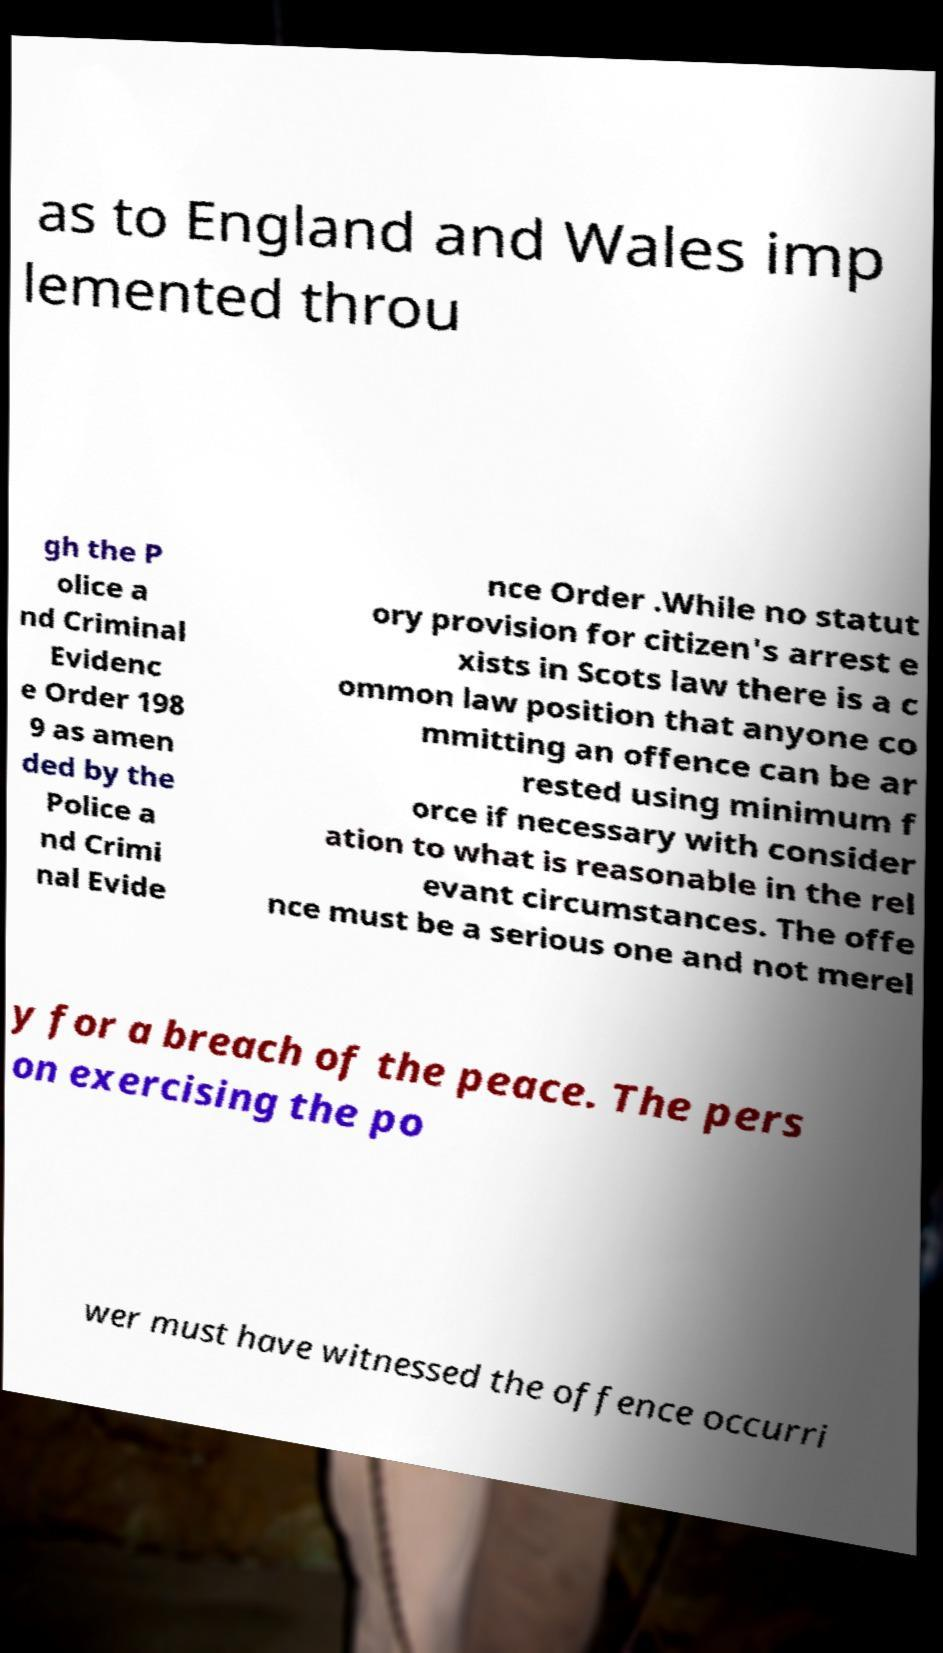Could you assist in decoding the text presented in this image and type it out clearly? as to England and Wales imp lemented throu gh the P olice a nd Criminal Evidenc e Order 198 9 as amen ded by the Police a nd Crimi nal Evide nce Order .While no statut ory provision for citizen's arrest e xists in Scots law there is a c ommon law position that anyone co mmitting an offence can be ar rested using minimum f orce if necessary with consider ation to what is reasonable in the rel evant circumstances. The offe nce must be a serious one and not merel y for a breach of the peace. The pers on exercising the po wer must have witnessed the offence occurri 